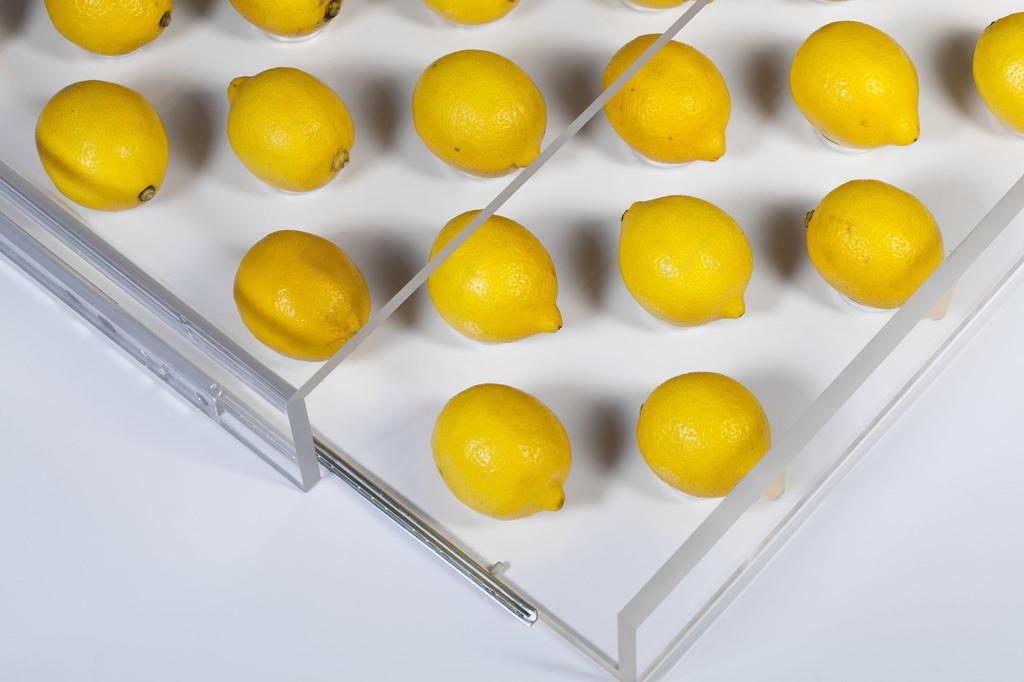What type of fruit is present in the image? There are lemons in the image. What is the opinion of the lemons about the market exchange in the image? There is no indication of a market exchange or any opinions in the image, as it only features lemons. 